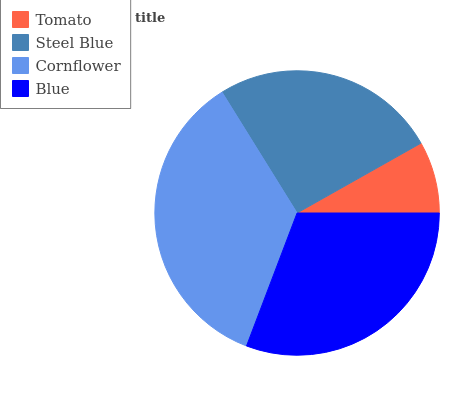Is Tomato the minimum?
Answer yes or no. Yes. Is Cornflower the maximum?
Answer yes or no. Yes. Is Steel Blue the minimum?
Answer yes or no. No. Is Steel Blue the maximum?
Answer yes or no. No. Is Steel Blue greater than Tomato?
Answer yes or no. Yes. Is Tomato less than Steel Blue?
Answer yes or no. Yes. Is Tomato greater than Steel Blue?
Answer yes or no. No. Is Steel Blue less than Tomato?
Answer yes or no. No. Is Blue the high median?
Answer yes or no. Yes. Is Steel Blue the low median?
Answer yes or no. Yes. Is Tomato the high median?
Answer yes or no. No. Is Cornflower the low median?
Answer yes or no. No. 